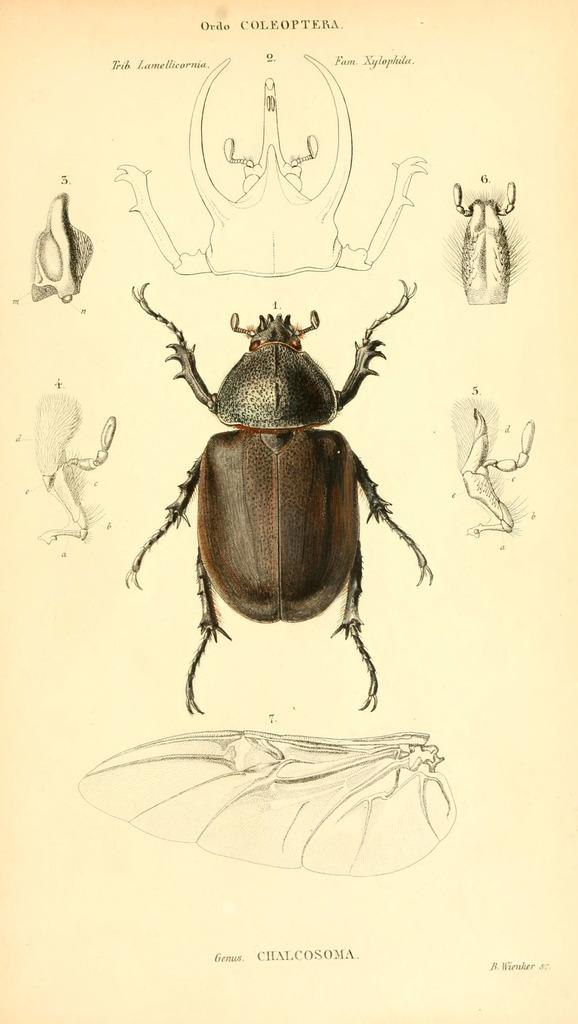What is present in the image that contains visual information? There is a paper in the image that contains visual information. What type of animal is depicted on the paper? The paper contains pictures of a reptile. What specific parts of the reptile are shown on the paper? The paper contains pictures of the reptile's parts. Is there any written information on the paper? Yes, there is text on the paper. What type of produce is being sold in the image? There is no produce being sold in the image; it features a paper with pictures of a reptile and its parts. 